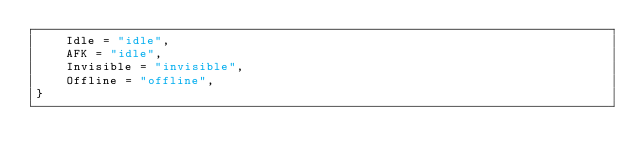<code> <loc_0><loc_0><loc_500><loc_500><_TypeScript_>    Idle = "idle",
    AFK = "idle",
    Invisible = "invisible",
    Offline = "offline",
}
</code> 